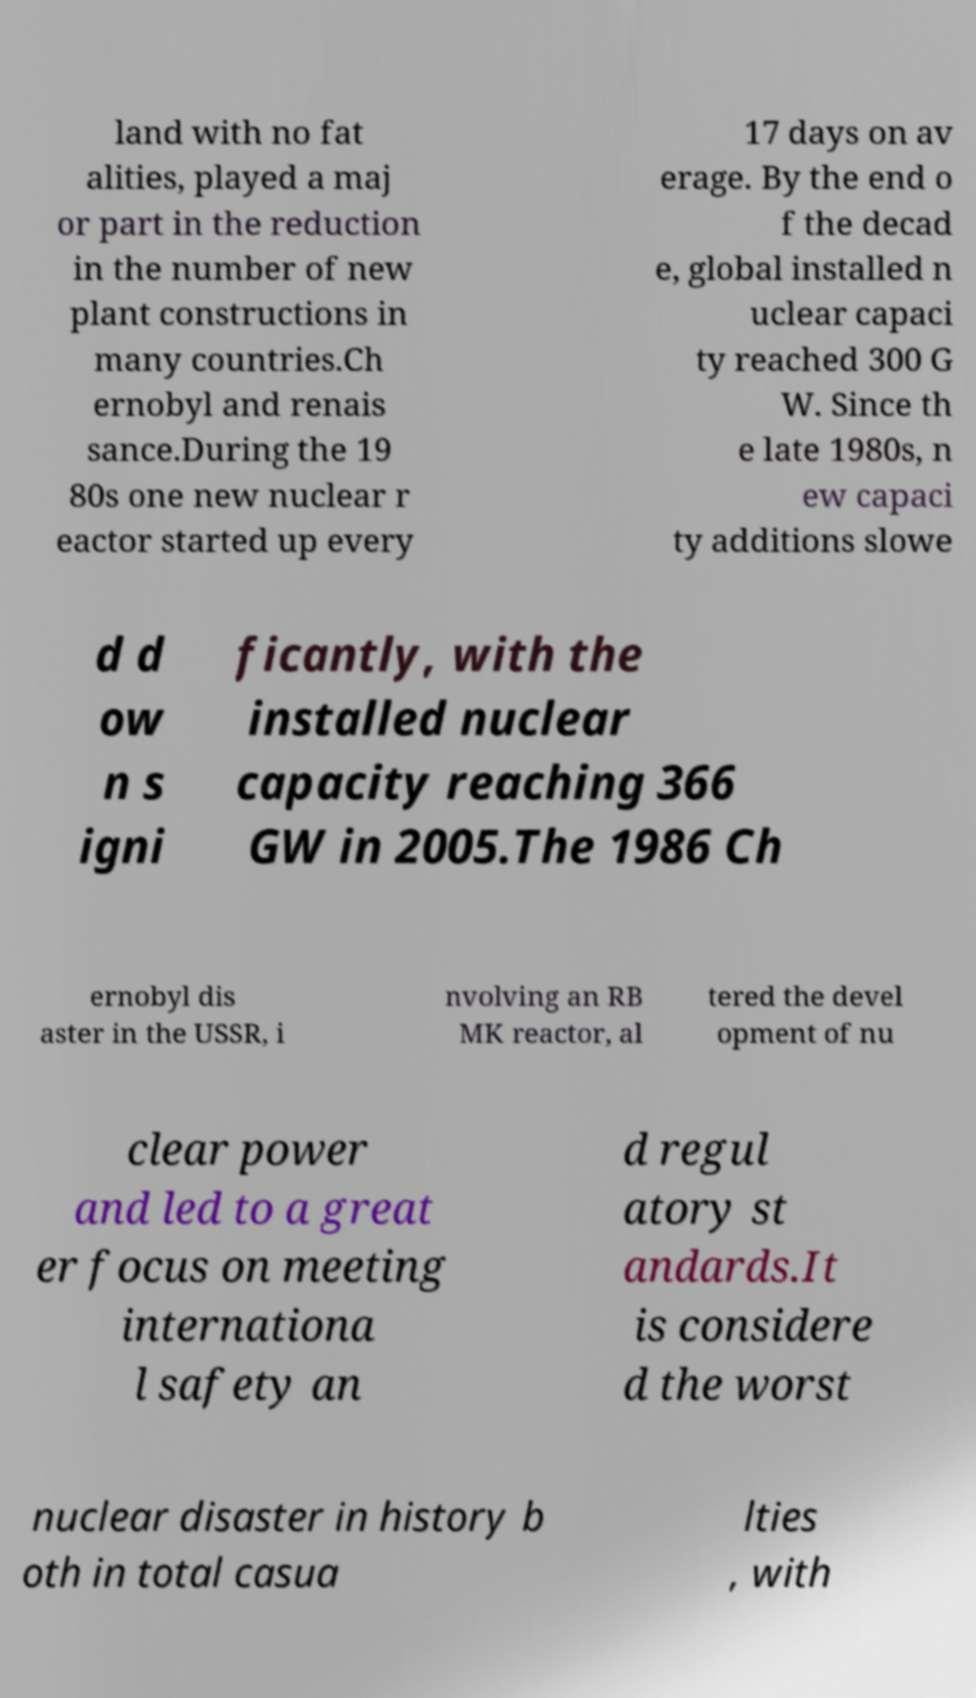For documentation purposes, I need the text within this image transcribed. Could you provide that? land with no fat alities, played a maj or part in the reduction in the number of new plant constructions in many countries.Ch ernobyl and renais sance.During the 19 80s one new nuclear r eactor started up every 17 days on av erage. By the end o f the decad e, global installed n uclear capaci ty reached 300 G W. Since th e late 1980s, n ew capaci ty additions slowe d d ow n s igni ficantly, with the installed nuclear capacity reaching 366 GW in 2005.The 1986 Ch ernobyl dis aster in the USSR, i nvolving an RB MK reactor, al tered the devel opment of nu clear power and led to a great er focus on meeting internationa l safety an d regul atory st andards.It is considere d the worst nuclear disaster in history b oth in total casua lties , with 